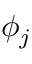Convert formula to latex. <formula><loc_0><loc_0><loc_500><loc_500>\phi _ { j }</formula> 